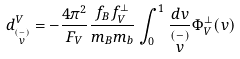Convert formula to latex. <formula><loc_0><loc_0><loc_500><loc_500>d _ { \stackrel { ( - ) } { v } } ^ { V } = - \frac { 4 \pi ^ { 2 } } { F _ { V } } \frac { f _ { B } f _ { V } ^ { \perp } } { m _ { B } m _ { b } } \int _ { 0 } ^ { 1 } \frac { d v } { \stackrel { ( - ) } { v } } \Phi _ { V } ^ { \perp } ( v )</formula> 